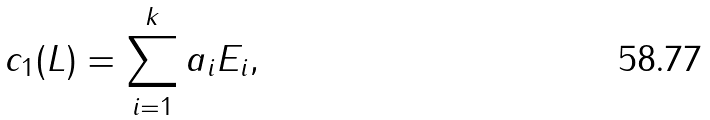<formula> <loc_0><loc_0><loc_500><loc_500>c _ { 1 } ( L ) = \sum _ { i = 1 } ^ { k } a _ { i } E _ { i } ,</formula> 